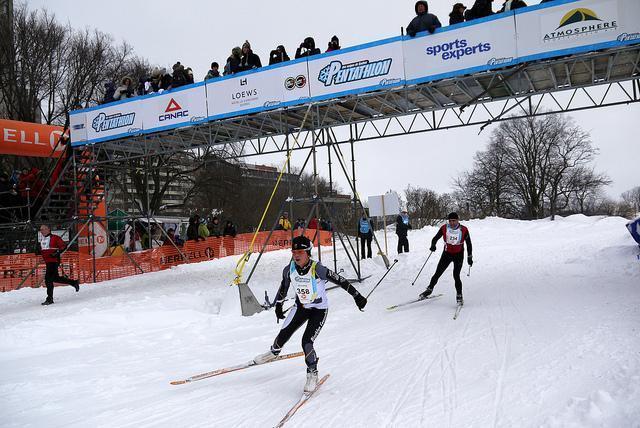How many people are skiing?
Give a very brief answer. 2. How many people can be seen?
Give a very brief answer. 3. How many kites are present?
Give a very brief answer. 0. 